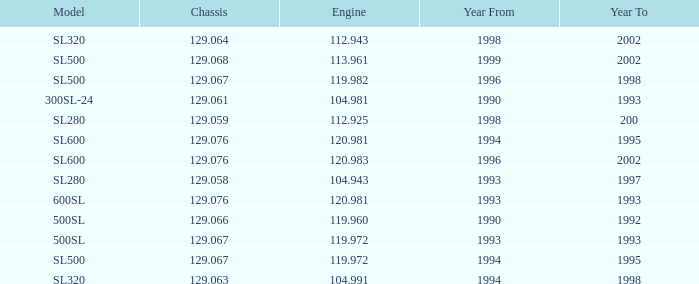How many engines have a Model of sl600, and a Year From of 1994, and a Year To smaller than 1995? 0.0. 